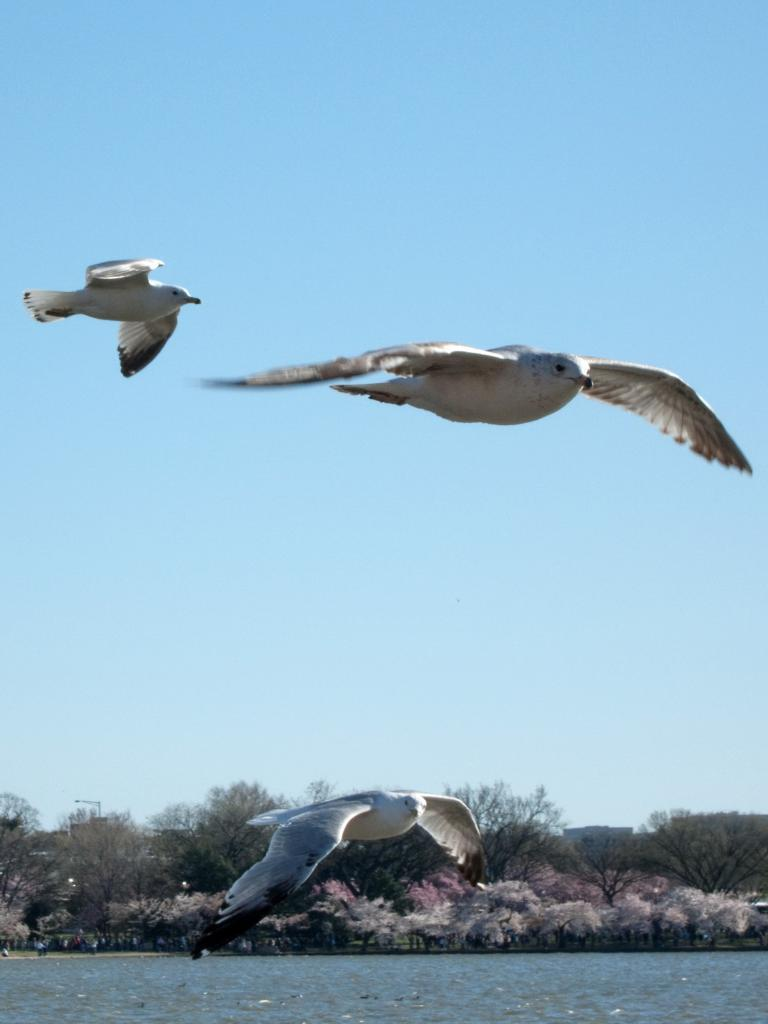What type of animals can be seen in the image? There are birds in the image. What color are the birds? The birds are white in color. What are the birds doing in the image? The birds are flying in the air. What can be seen at the bottom of the image? There is water visible at the bottom of the image. What is visible in the background of the image? There are rocks and trees in the background of the image. What is visible at the top of the image? The sky is visible at the top of the image. How many quarters can be seen in the image? There are no quarters present in the image. Are the birds sleeping in the image? The birds are flying in the air, not sleeping. 